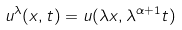Convert formula to latex. <formula><loc_0><loc_0><loc_500><loc_500>u ^ { \lambda } ( x , t ) = u ( \lambda x , \lambda ^ { \alpha + 1 } t )</formula> 